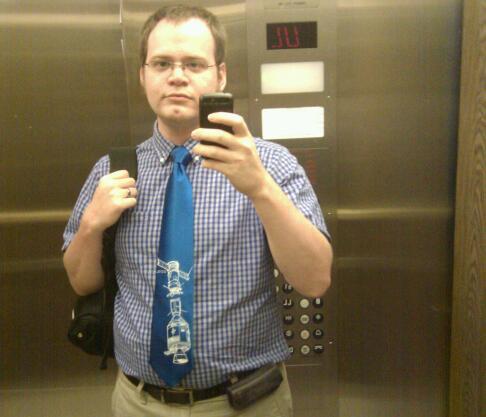Is the man wearing a tie?
Quick response, please. Yes. Is this person in an elevator?
Keep it brief. Yes. Is the man taking a picture of himself?
Keep it brief. Yes. 